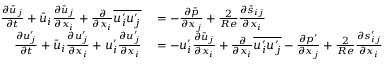Convert formula to latex. <formula><loc_0><loc_0><loc_500><loc_500>\begin{array} { r l } { \frac { \partial \bar { u } _ { j } } { \partial t } + \bar { u } _ { i } \frac { \partial \bar { u } _ { j } } { \partial x _ { i } } + \frac { \partial } { \partial x _ { i } } \overline { { u _ { i } ^ { \prime } u _ { j } ^ { \prime } } } } & = - \frac { \partial \bar { p } } { \partial x _ { j } } + \frac { 2 } { R e } \frac { \partial \bar { s } _ { i j } } { \partial x _ { i } } } \\ { \frac { \partial u _ { j } ^ { \prime } } { \partial t } + \bar { u } _ { i } \frac { \partial u _ { j } ^ { \prime } } { \partial x _ { i } } + u _ { i } ^ { \prime } \frac { \partial u _ { j } ^ { \prime } } { \partial x _ { i } } } & = - u _ { i } ^ { \prime } \frac { \partial \bar { u } _ { j } } { \partial x _ { i } } + \frac { \partial } { \partial x _ { i } } \overline { { u _ { i } ^ { \prime } u _ { j } ^ { \prime } } } - \frac { \partial p ^ { \prime } } { \partial x _ { j } } + \frac { 2 } { R e } \frac { \partial s _ { i j } ^ { \prime } } { \partial x _ { i } } } \end{array}</formula> 